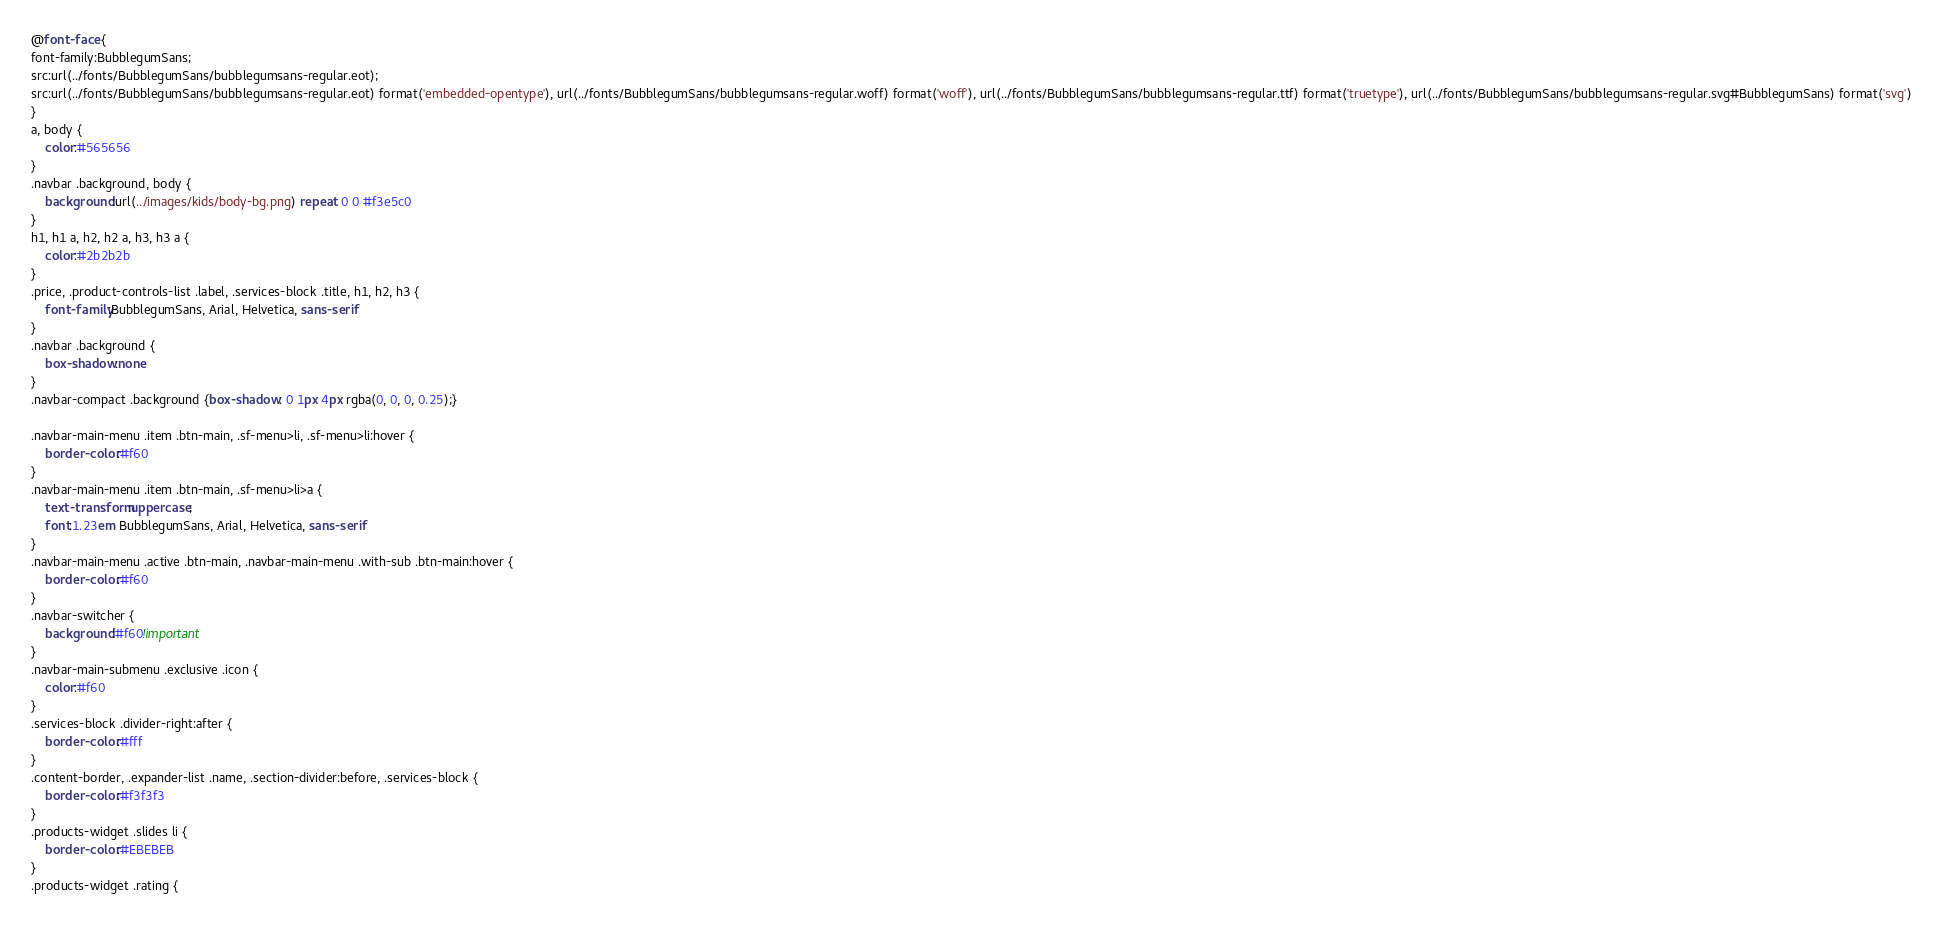<code> <loc_0><loc_0><loc_500><loc_500><_CSS_>@font-face {
font-family:BubblegumSans;
src:url(../fonts/BubblegumSans/bubblegumsans-regular.eot);
src:url(../fonts/BubblegumSans/bubblegumsans-regular.eot) format('embedded-opentype'), url(../fonts/BubblegumSans/bubblegumsans-regular.woff) format('woff'), url(../fonts/BubblegumSans/bubblegumsans-regular.ttf) format('truetype'), url(../fonts/BubblegumSans/bubblegumsans-regular.svg#BubblegumSans) format('svg')
}
a, body {
	color:#565656
}
.navbar .background, body {
	background:url(../images/kids/body-bg.png) repeat 0 0 #f3e5c0
}
h1, h1 a, h2, h2 a, h3, h3 a {
	color:#2b2b2b
}
.price, .product-controls-list .label, .services-block .title, h1, h2, h3 {
	font-family:BubblegumSans, Arial, Helvetica, sans-serif
}
.navbar .background {
	box-shadow:none
}
.navbar-compact .background {box-shadow: 0 1px 4px rgba(0, 0, 0, 0.25);}

.navbar-main-menu .item .btn-main, .sf-menu>li, .sf-menu>li:hover {
	border-color:#f60
}
.navbar-main-menu .item .btn-main, .sf-menu>li>a {
	text-transform:uppercase;
	font:1.23em BubblegumSans, Arial, Helvetica, sans-serif
}
.navbar-main-menu .active .btn-main, .navbar-main-menu .with-sub .btn-main:hover {
	border-color:#f60
}
.navbar-switcher {
	background:#f60!important
}
.navbar-main-submenu .exclusive .icon {
	color:#f60
}
.services-block .divider-right:after {
	border-color:#fff
}
.content-border, .expander-list .name, .section-divider:before, .services-block {
	border-color:#f3f3f3
}
.products-widget .slides li {
	border-color:#EBEBEB
}
.products-widget .rating {</code> 